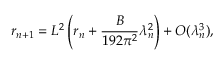Convert formula to latex. <formula><loc_0><loc_0><loc_500><loc_500>r _ { n + 1 } = L ^ { 2 } \left ( r _ { n } + \frac { B } { 1 9 2 \pi ^ { 2 } } \lambda _ { n } ^ { 2 } \right ) + O ( \lambda _ { n } ^ { 3 } ) ,</formula> 